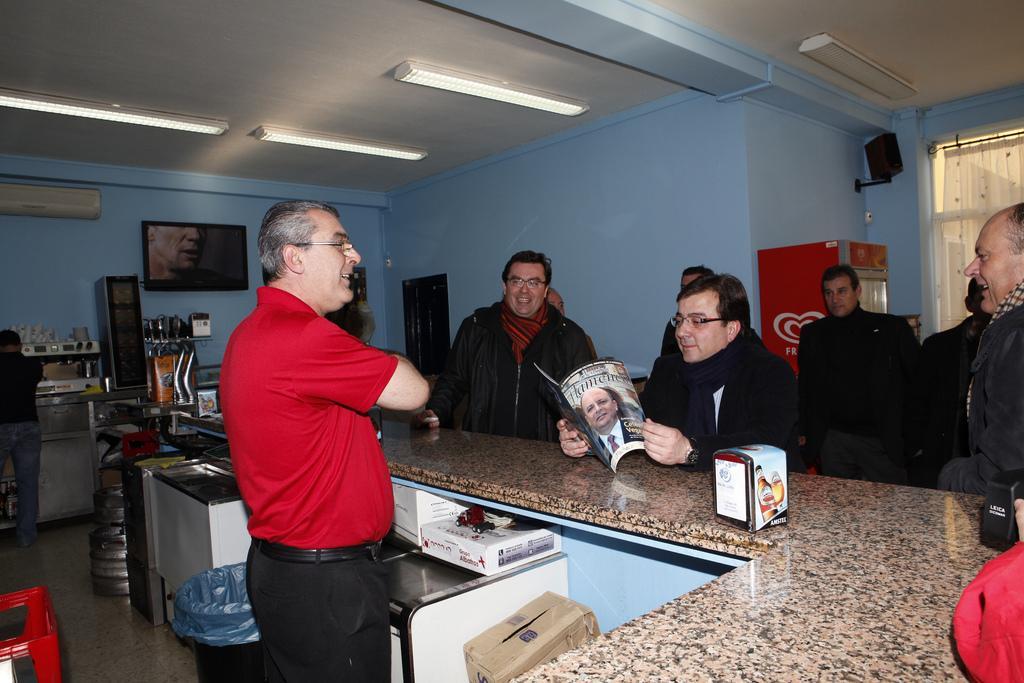In one or two sentences, can you explain what this image depicts? In the picture I can see a person wearing red color T-shirt is standing here. In the background, we can see a few more people wearing black jackets are standing and this person is holding a magazine and standing here. Here we can see cardboard boxes, some objects, air conditioner, television, refrigerator, speaker box, curtains and ceiling lights. 